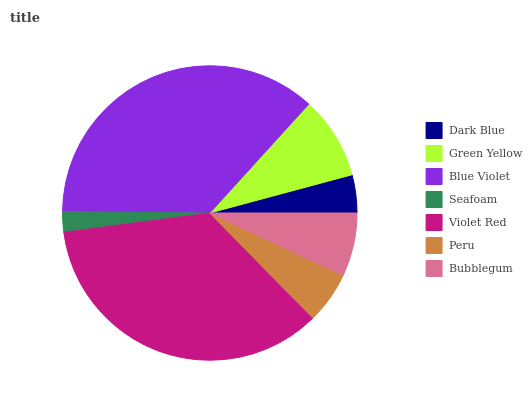Is Seafoam the minimum?
Answer yes or no. Yes. Is Blue Violet the maximum?
Answer yes or no. Yes. Is Green Yellow the minimum?
Answer yes or no. No. Is Green Yellow the maximum?
Answer yes or no. No. Is Green Yellow greater than Dark Blue?
Answer yes or no. Yes. Is Dark Blue less than Green Yellow?
Answer yes or no. Yes. Is Dark Blue greater than Green Yellow?
Answer yes or no. No. Is Green Yellow less than Dark Blue?
Answer yes or no. No. Is Bubblegum the high median?
Answer yes or no. Yes. Is Bubblegum the low median?
Answer yes or no. Yes. Is Peru the high median?
Answer yes or no. No. Is Seafoam the low median?
Answer yes or no. No. 